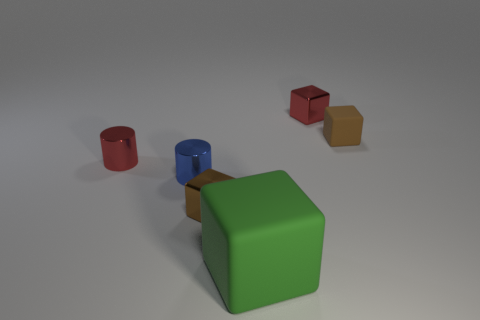Subtract all brown metal blocks. How many blocks are left? 3 Subtract all cyan balls. How many brown cubes are left? 2 Add 1 small metal things. How many objects exist? 7 Subtract all brown cubes. How many cubes are left? 2 Add 3 small red blocks. How many small red blocks are left? 4 Add 3 small blocks. How many small blocks exist? 6 Subtract 1 red blocks. How many objects are left? 5 Subtract all cubes. How many objects are left? 2 Subtract 1 blocks. How many blocks are left? 3 Subtract all gray cubes. Subtract all blue cylinders. How many cubes are left? 4 